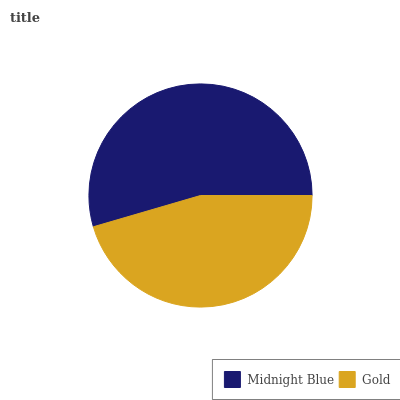Is Gold the minimum?
Answer yes or no. Yes. Is Midnight Blue the maximum?
Answer yes or no. Yes. Is Gold the maximum?
Answer yes or no. No. Is Midnight Blue greater than Gold?
Answer yes or no. Yes. Is Gold less than Midnight Blue?
Answer yes or no. Yes. Is Gold greater than Midnight Blue?
Answer yes or no. No. Is Midnight Blue less than Gold?
Answer yes or no. No. Is Midnight Blue the high median?
Answer yes or no. Yes. Is Gold the low median?
Answer yes or no. Yes. Is Gold the high median?
Answer yes or no. No. Is Midnight Blue the low median?
Answer yes or no. No. 